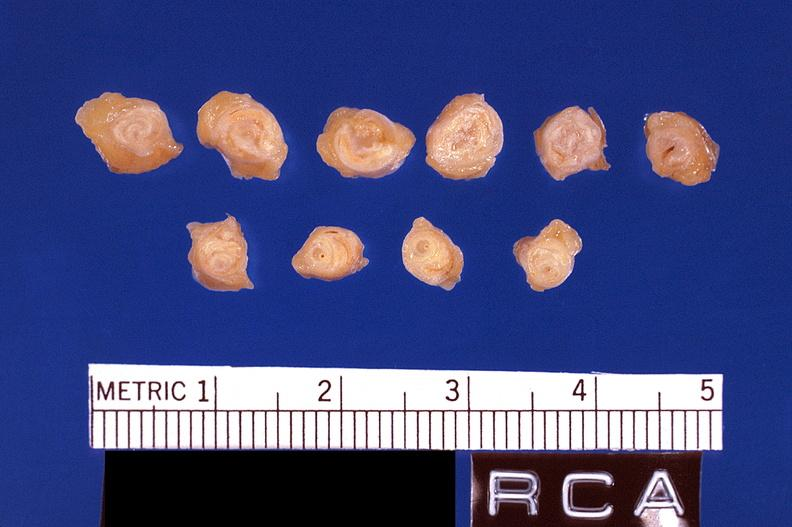s vasculature present?
Answer the question using a single word or phrase. Yes 